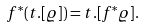<formula> <loc_0><loc_0><loc_500><loc_500>f ^ { * } ( t . [ \varrho ] ) = t . [ f ^ { * } \varrho ] .</formula> 